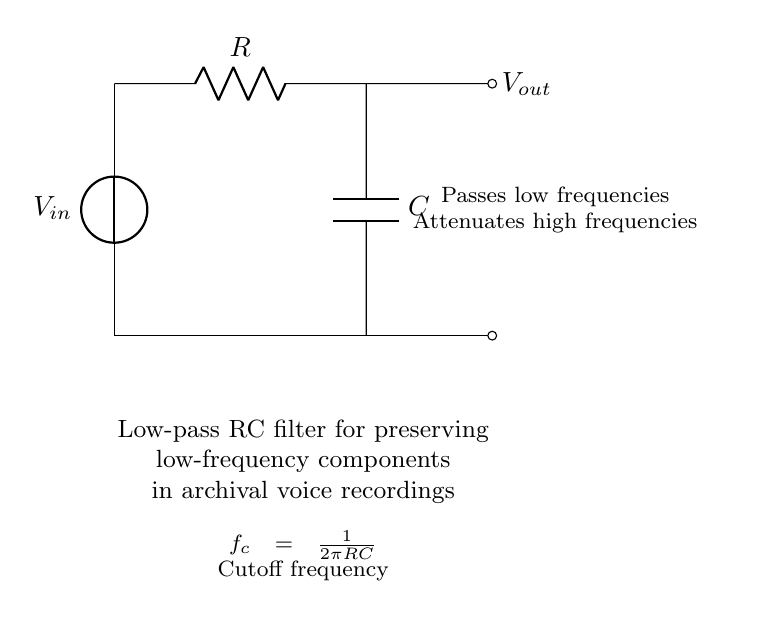What is the input voltage source labeled as? The input voltage source is labeled as V_in, indicating where the input signal is applied to the circuit.
Answer: V_in What is the component connected to the input voltage? The component connected to the input voltage is a resistor, marked as R, which is placed in series with the voltage source.
Answer: R What is the cutoff frequency equation for this low-pass filter? The cutoff frequency is indicated in the circuit diagram as f_c = 1/(2πRC), which shows how the resistor and capacitor values determine the frequency at which the output starts to decrease.
Answer: f_c = 1/(2πRC) What frequencies does this low-pass filter primarily pass? The low-pass filter is designed to pass low frequencies, meaning it allows signals with lower frequencies to reach the output while attenuating higher frequencies.
Answer: Low frequencies What happens to high frequencies in this circuit? High frequencies are attenuated by the filter, which means that signals with higher frequencies are reduced or diminished at the output compared to low frequencies.
Answer: Attenuated How does increasing the resistor value R affect the cutoff frequency? Increasing the resistance (R) in the formula for cutoff frequency (f_c = 1/(2πRC)) results in a lower cutoff frequency, meaning the circuit would block more higher frequencies.
Answer: Lower cutoff frequency 